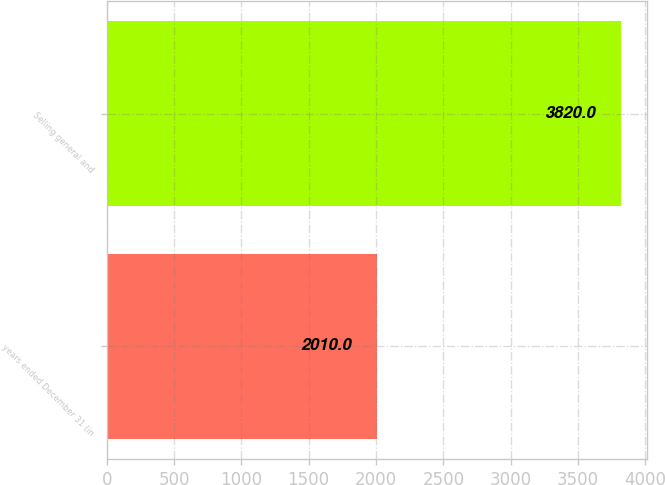Convert chart to OTSL. <chart><loc_0><loc_0><loc_500><loc_500><bar_chart><fcel>years ended December 31 (in<fcel>Selling general and<nl><fcel>2010<fcel>3820<nl></chart> 